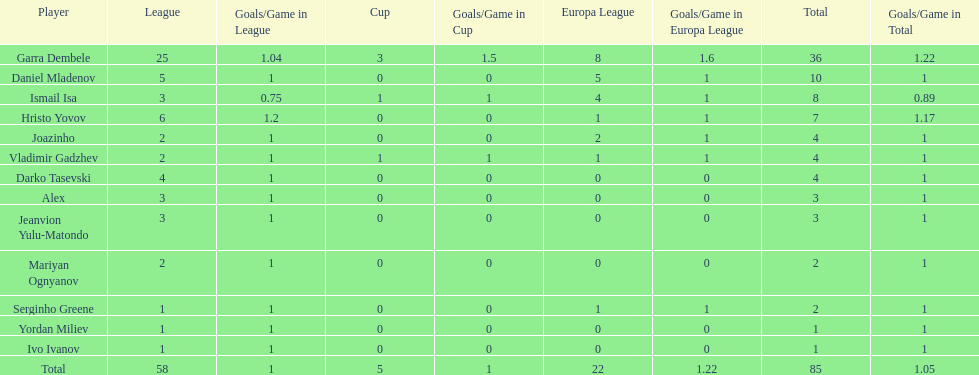During the cup, how many players were unable to score any goals? 10. 